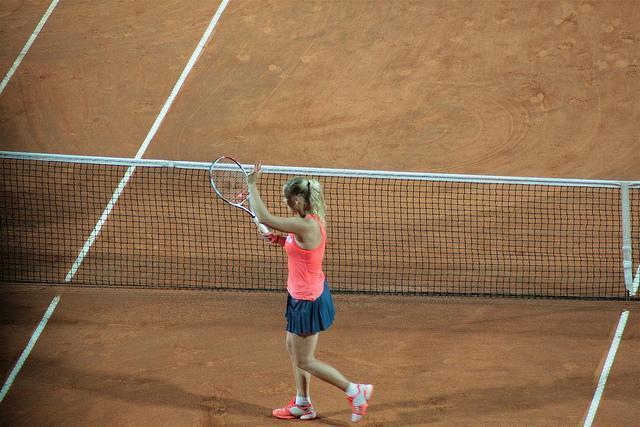How many people in this photo?
Give a very brief answer. 1. 